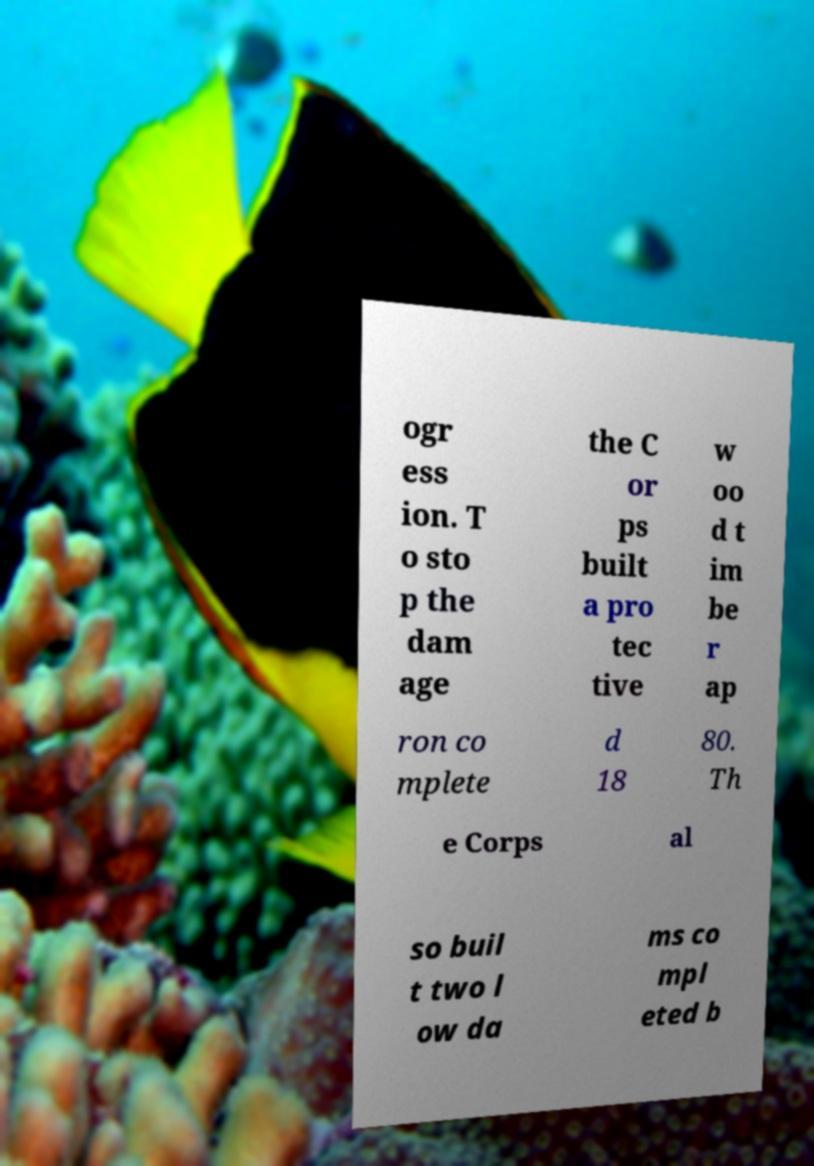Could you extract and type out the text from this image? ogr ess ion. T o sto p the dam age the C or ps built a pro tec tive w oo d t im be r ap ron co mplete d 18 80. Th e Corps al so buil t two l ow da ms co mpl eted b 